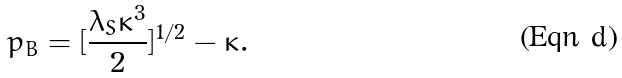<formula> <loc_0><loc_0><loc_500><loc_500>p _ { B } = [ \frac { \lambda _ { S } \kappa ^ { 3 } } { 2 } ] ^ { 1 / 2 } - \kappa .</formula> 